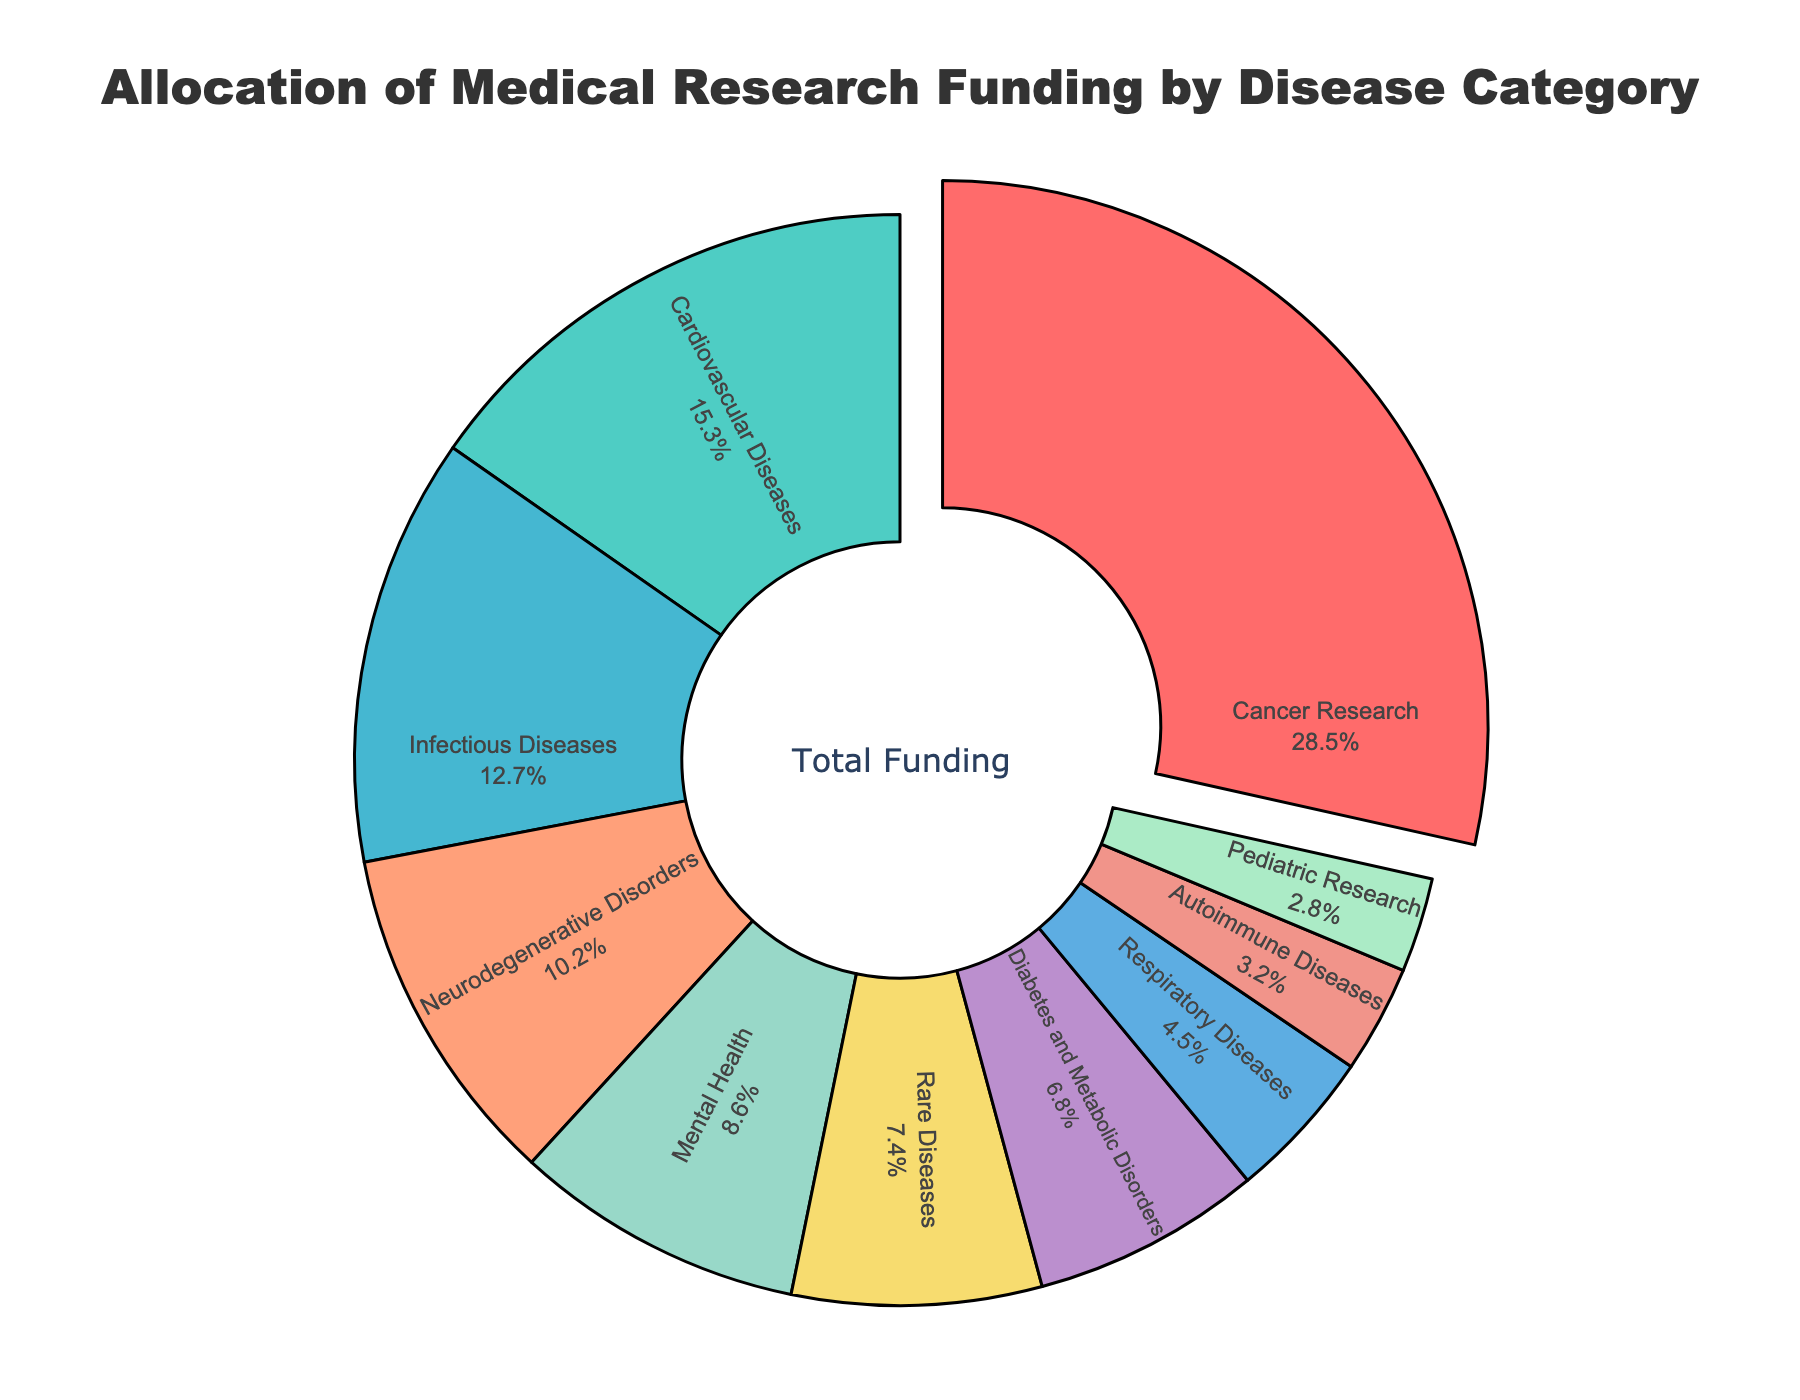What percentage of funding is allocated to Cancer Research, and how does it compare to the funding for Cardiovascular Diseases? Cancer Research has 28.5% of funding allocation, and Cardiovascular Diseases have 15.3%. To find the difference, subtract 15.3 from 28.5, which gives 13.2.
Answer: 13.2% What is the combined funding allocation for Infectious Diseases, Respiratory Diseases, and Autoimmune Diseases? Sum the percentages for Infectious Diseases (12.7%), Respiratory Diseases (4.5%), and Autoimmune Diseases (3.2%). The combined funding is 12.7 + 4.5 + 3.2 = 20.4%.
Answer: 20.4% Is funding for Neurodegenerative Disorders higher or lower than Mental Health? Neurodegenerative Disorders have 10.2% of funding, while Mental Health has 8.6%. 10.2 is higher than 8.6.
Answer: Higher Which disease category has the least funding, and what is its percentage? The category with the least funding is Pediatric Research with 2.8%.
Answer: Pediatric Research, 2.8% How much more funding is allocated to Diabetes and Metabolic Disorders compared to Rare Diseases? Rare Diseases have 7.4%, and Diabetes and Metabolic Disorders have 6.8%. Subtract 6.8 from 7.4 to get 0.6%.
Answer: 0.6% What's the average funding allocation of Cancer Research, Cardiovascular Diseases, and Infectious Diseases? Sum the percentages for Cancer Research (28.5%), Cardiovascular Diseases (15.3%), and Infectious Diseases (12.7%), which is 28.5 + 15.3 + 12.7 = 56.5%. Divide by three (number of categories) to get the average: 56.5/3 ≈ 18.83%.
Answer: 18.83% What two categories together receive around the same amount of funding as Cancer Research alone? Cancer Research has 28.5%. Summing Cardiovascular Diseases (15.3%) and Diabetes and Metabolic Disorders (6.8%) gives 15.3 + 6.8 = 22.1%. Summing Cardiovascular Diseases (15.3%) and Mental Health (8.6%) gives 15.3 + 8.6 = 23.9%. Summing Mental Health (8.6%) and Infectious Diseases (12.7%) gives 8.6 + 12.7 = 21.3%. Summing Mental Health (8.6%) and Neurodegenerative Disorders (10.2%) gives 8.6 + 10.2 = 18.8%. The pair that is closest to 28.5% is Cardiovascular Diseases and Rare Diseases: 15.3 + 7.4 = 22.7%. Considering potential small differences, Rare Diseases and Diabetes and Metabolic Disorders is the better pair: 7.4 + 6.8 = 14.2%. Note that none pair exactly matches but for the closest we consider Cancer Research alone can match Rare Diseases and Diabetes group.
Answer: Rare Diseases and Diabetes and Metabolic Disorders What percentage of the total funding is allocated to the top three funded categories? The top three funded categories are Cancer Research (28.5%), Cardiovascular Diseases (15.3%), and Infectious Diseases (12.7%). Sum these percentages to get 28.5 + 15.3 + 12.7 = 56.5%.
Answer: 56.5% Which category has a smaller funding allocation: Respiratory Diseases or Autoimmune Diseases? Respiratory Diseases have 4.5%, and Autoimmune Diseases have 3.2%. Autoimmune Diseases have a smaller allocation.
Answer: Autoimmune Diseases What is the combined funding allocation for the categories that have less than 10% each? Categories with less than 10% are Mental Health (8.6%), Rare Diseases (7.4%), Diabetes and Metabolic Disorders (6.8%), Respiratory Diseases (4.5%), Autoimmune Diseases (3.2%), and Pediatric Research (2.8%). Sum these to get 8.6 + 7.4 + 6.8 + 4.5 + 3.2 + 2.8 = 33.3%.
Answer: 33.3% 